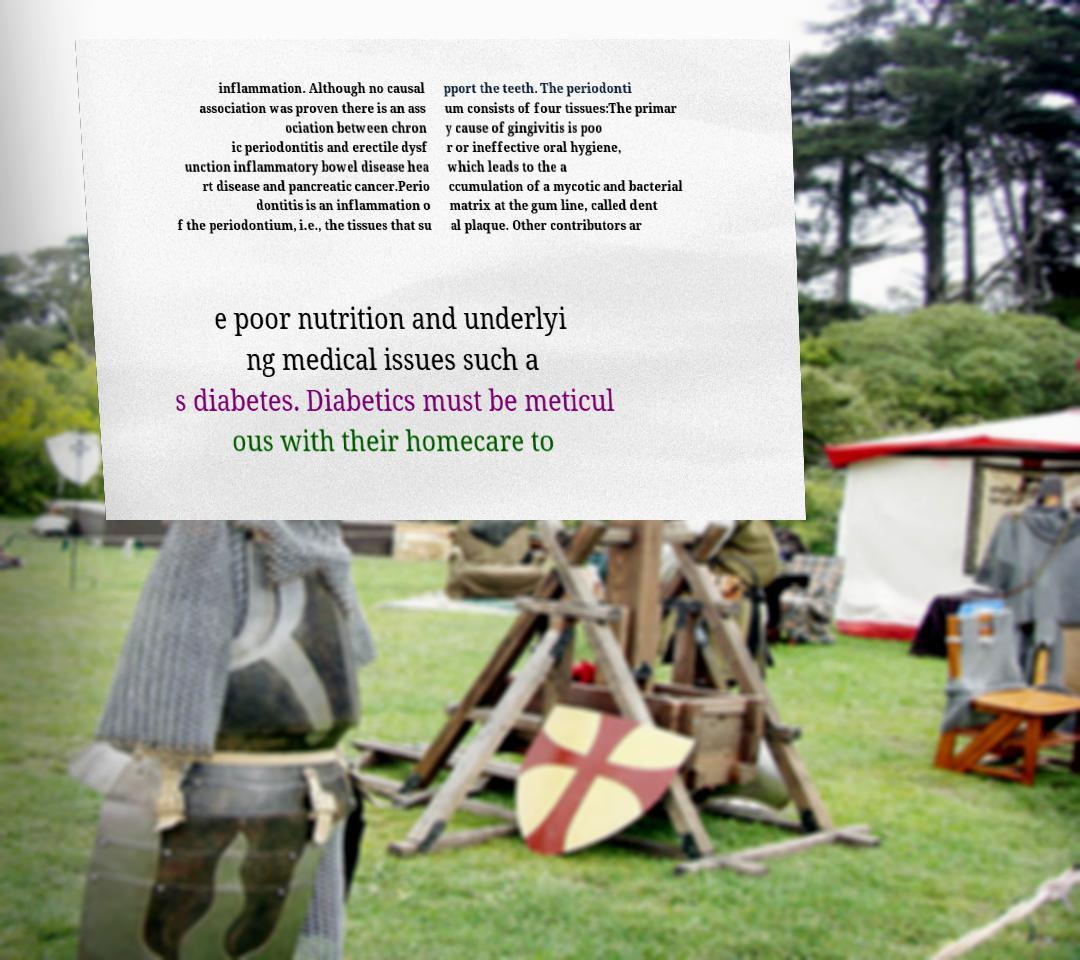Could you extract and type out the text from this image? inflammation. Although no causal association was proven there is an ass ociation between chron ic periodontitis and erectile dysf unction inflammatory bowel disease hea rt disease and pancreatic cancer.Perio dontitis is an inflammation o f the periodontium, i.e., the tissues that su pport the teeth. The periodonti um consists of four tissues:The primar y cause of gingivitis is poo r or ineffective oral hygiene, which leads to the a ccumulation of a mycotic and bacterial matrix at the gum line, called dent al plaque. Other contributors ar e poor nutrition and underlyi ng medical issues such a s diabetes. Diabetics must be meticul ous with their homecare to 